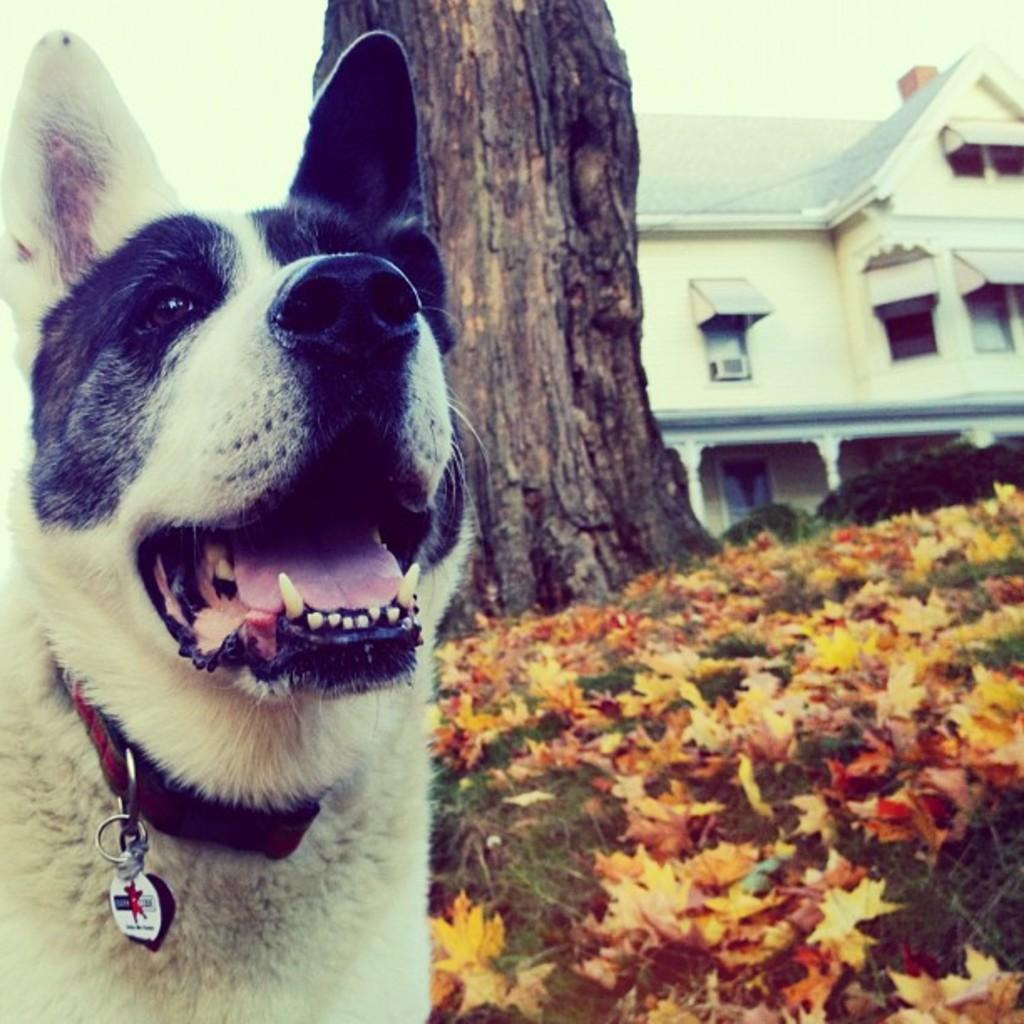What type of animal is on the left side of the image? There is a dog on the left side of the image. What kind of plants can be seen in the image? There are flower plants in the image. What part of a tree is visible in the image? The bark of a tree is visible in the image. What type of structure is on the right side of the image? There is a building on the right side of the image. What type of soda is the dog drinking in the image? There is no soda present in the image; it features a dog, flower plants, tree bark, and a building. How many chickens are visible in the image? There are no chickens present in the image. 